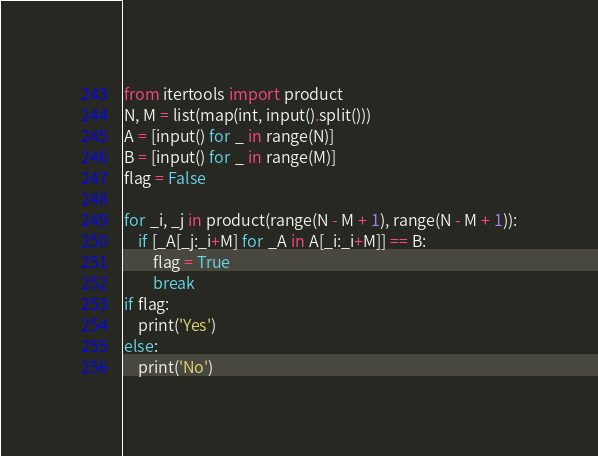Convert code to text. <code><loc_0><loc_0><loc_500><loc_500><_Python_>from itertools import product
N, M = list(map(int, input().split()))
A = [input() for _ in range(N)]
B = [input() for _ in range(M)]
flag = False

for _i, _j in product(range(N - M + 1), range(N - M + 1)):
    if [_A[_j:_i+M] for _A in A[_i:_i+M]] == B:
        flag = True
        break
if flag:
    print('Yes')
else:
    print('No')</code> 